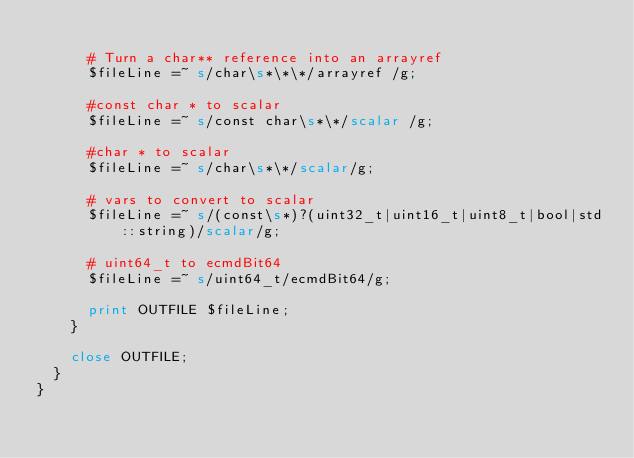<code> <loc_0><loc_0><loc_500><loc_500><_Perl_>
      # Turn a char** reference into an arrayref
      $fileLine =~ s/char\s*\*\*/arrayref /g;

      #const char * to scalar
      $fileLine =~ s/const char\s*\*/scalar /g;

      #char * to scalar
      $fileLine =~ s/char\s*\*/scalar/g;

      # vars to convert to scalar
      $fileLine =~ s/(const\s*)?(uint32_t|uint16_t|uint8_t|bool|std::string)/scalar/g;

      # uint64_t to ecmdBit64
      $fileLine =~ s/uint64_t/ecmdBit64/g;

      print OUTFILE $fileLine;
    }

    close OUTFILE;
  }
}
</code> 